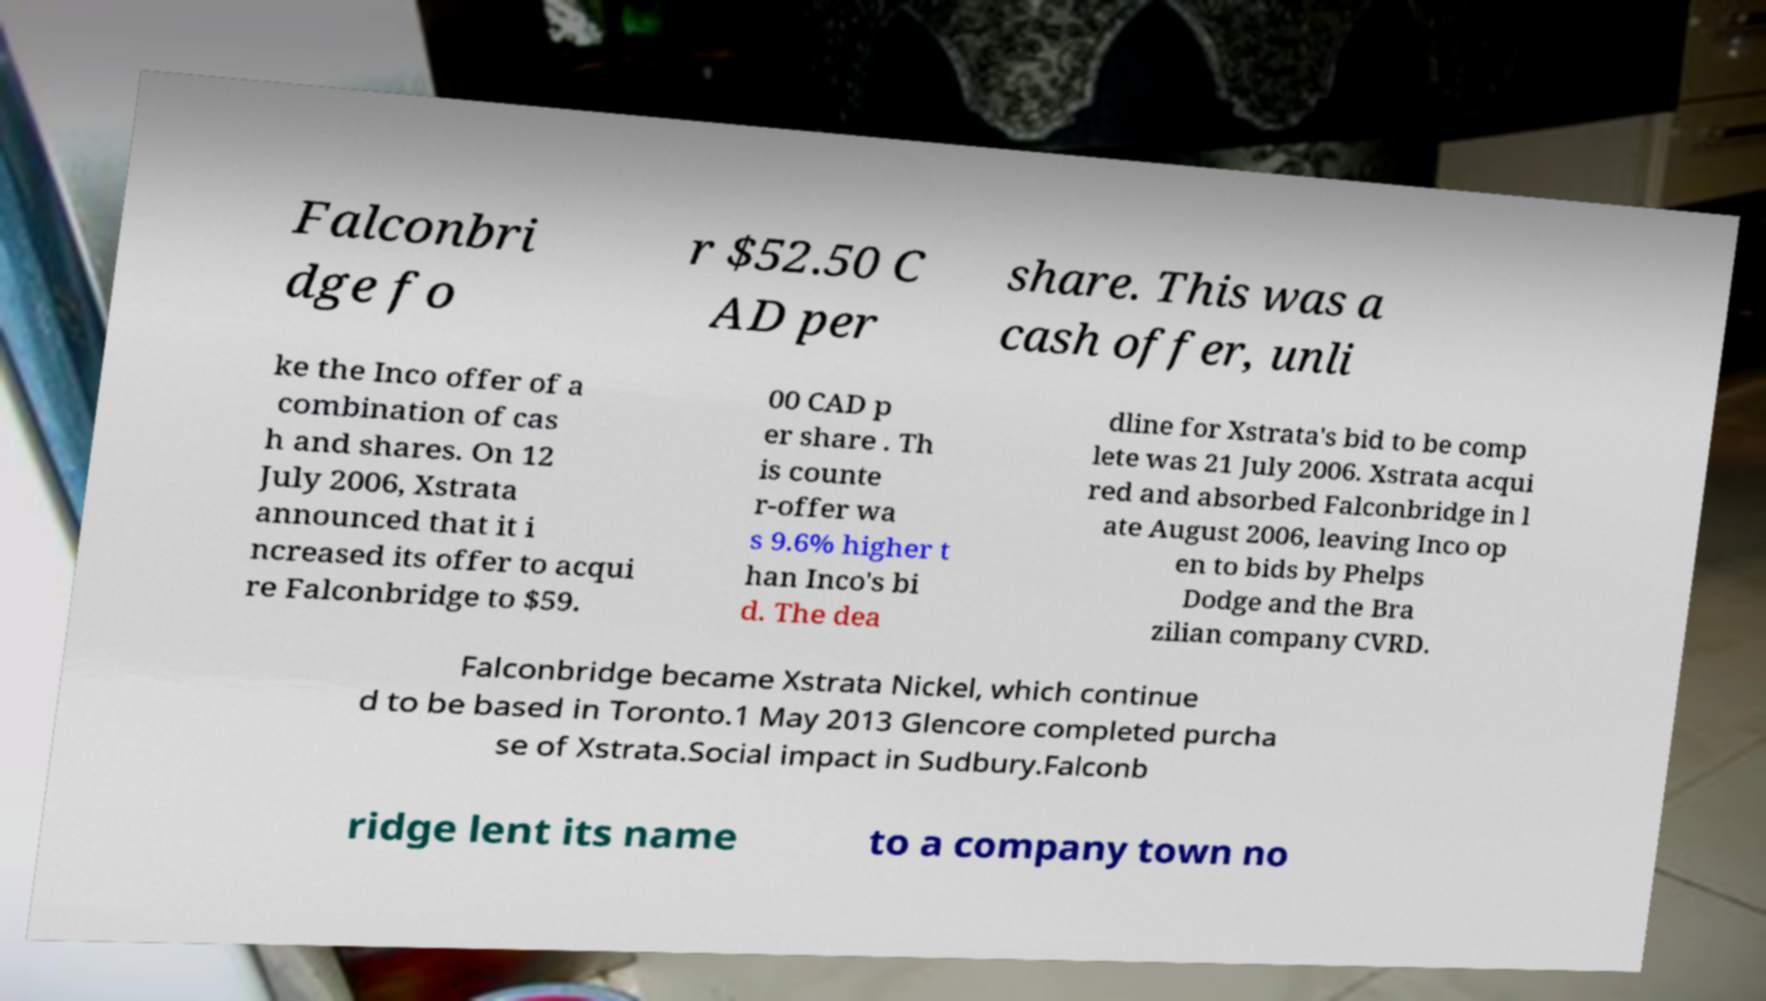Can you read and provide the text displayed in the image?This photo seems to have some interesting text. Can you extract and type it out for me? Falconbri dge fo r $52.50 C AD per share. This was a cash offer, unli ke the Inco offer of a combination of cas h and shares. On 12 July 2006, Xstrata announced that it i ncreased its offer to acqui re Falconbridge to $59. 00 CAD p er share . Th is counte r-offer wa s 9.6% higher t han Inco's bi d. The dea dline for Xstrata's bid to be comp lete was 21 July 2006. Xstrata acqui red and absorbed Falconbridge in l ate August 2006, leaving Inco op en to bids by Phelps Dodge and the Bra zilian company CVRD. Falconbridge became Xstrata Nickel, which continue d to be based in Toronto.1 May 2013 Glencore completed purcha se of Xstrata.Social impact in Sudbury.Falconb ridge lent its name to a company town no 